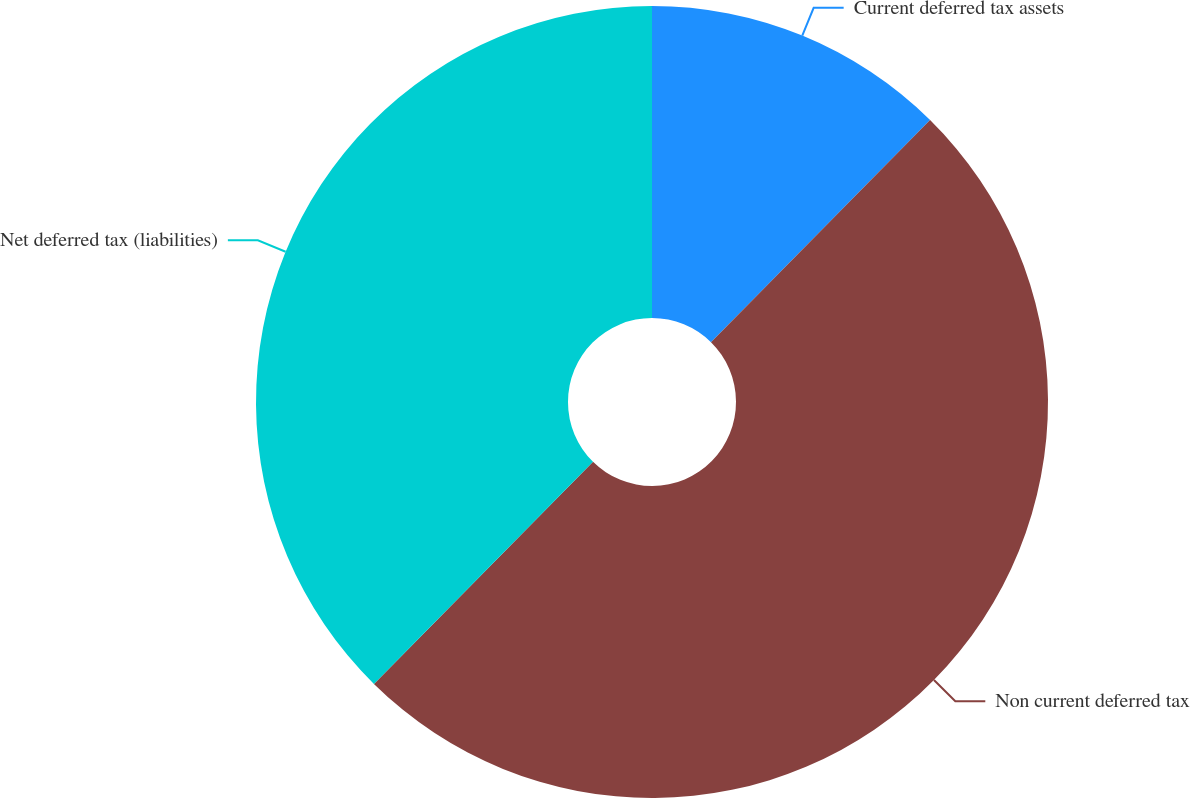Convert chart. <chart><loc_0><loc_0><loc_500><loc_500><pie_chart><fcel>Current deferred tax assets<fcel>Non current deferred tax<fcel>Net deferred tax (liabilities)<nl><fcel>12.39%<fcel>50.0%<fcel>37.61%<nl></chart> 